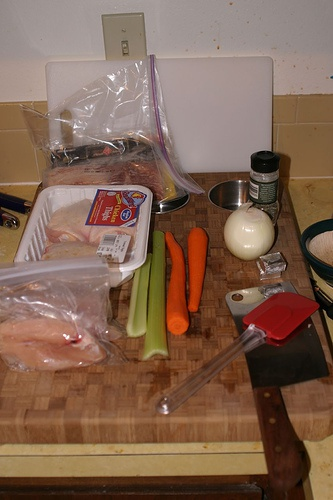Describe the objects in this image and their specific colors. I can see knife in gray, black, and maroon tones, carrot in gray, brown, red, and maroon tones, bowl in gray and black tones, and carrot in gray, brown, and maroon tones in this image. 